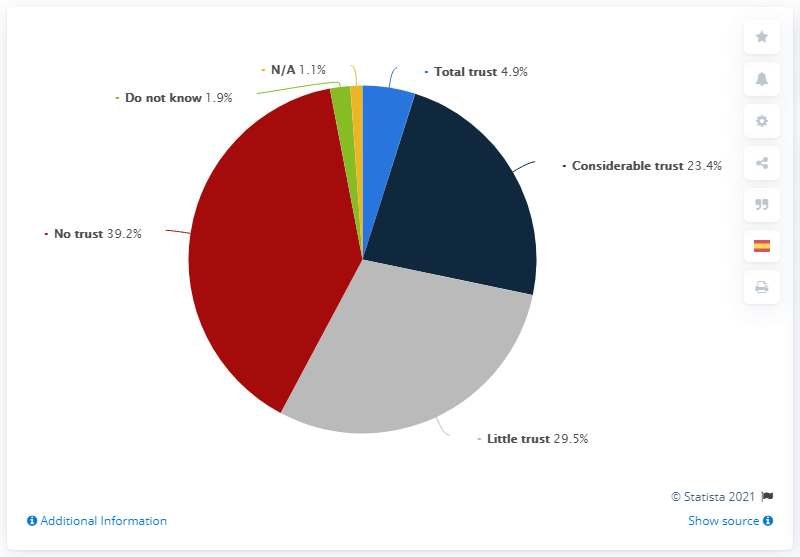What is the sum of the highest and lowest percentage in the chart? The sum of the highest and lowest percentage values in the chart is 40.3%. The lowest value is 'Total trust' at 4.9%, while the highest is 'No trust' at 35.4%. When these are combined, they equal 40.3%, indicating a significant variance in trust levels represented within the dataset. 